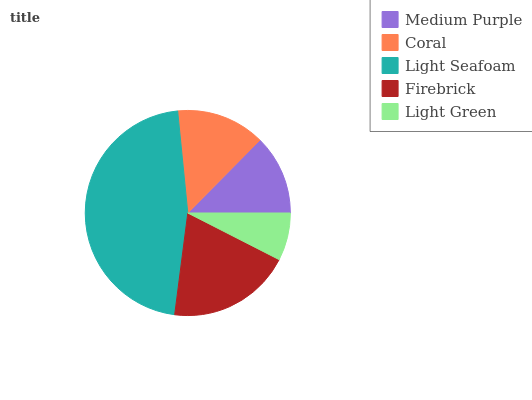Is Light Green the minimum?
Answer yes or no. Yes. Is Light Seafoam the maximum?
Answer yes or no. Yes. Is Coral the minimum?
Answer yes or no. No. Is Coral the maximum?
Answer yes or no. No. Is Coral greater than Medium Purple?
Answer yes or no. Yes. Is Medium Purple less than Coral?
Answer yes or no. Yes. Is Medium Purple greater than Coral?
Answer yes or no. No. Is Coral less than Medium Purple?
Answer yes or no. No. Is Coral the high median?
Answer yes or no. Yes. Is Coral the low median?
Answer yes or no. Yes. Is Light Seafoam the high median?
Answer yes or no. No. Is Light Green the low median?
Answer yes or no. No. 